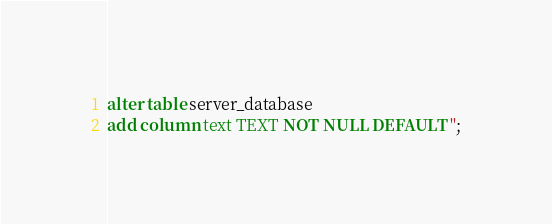<code> <loc_0><loc_0><loc_500><loc_500><_SQL_>alter table server_database
add column text TEXT NOT NULL DEFAULT '';
</code> 